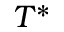<formula> <loc_0><loc_0><loc_500><loc_500>T ^ { * }</formula> 